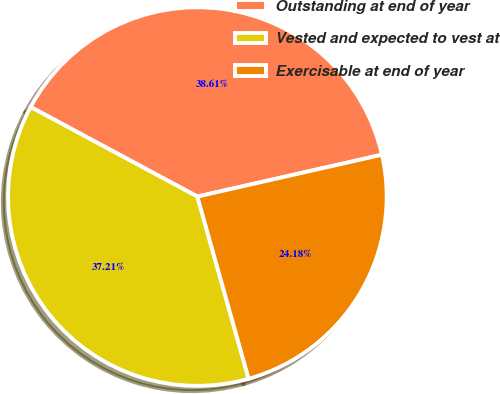<chart> <loc_0><loc_0><loc_500><loc_500><pie_chart><fcel>Outstanding at end of year<fcel>Vested and expected to vest at<fcel>Exercisable at end of year<nl><fcel>38.61%<fcel>37.21%<fcel>24.18%<nl></chart> 